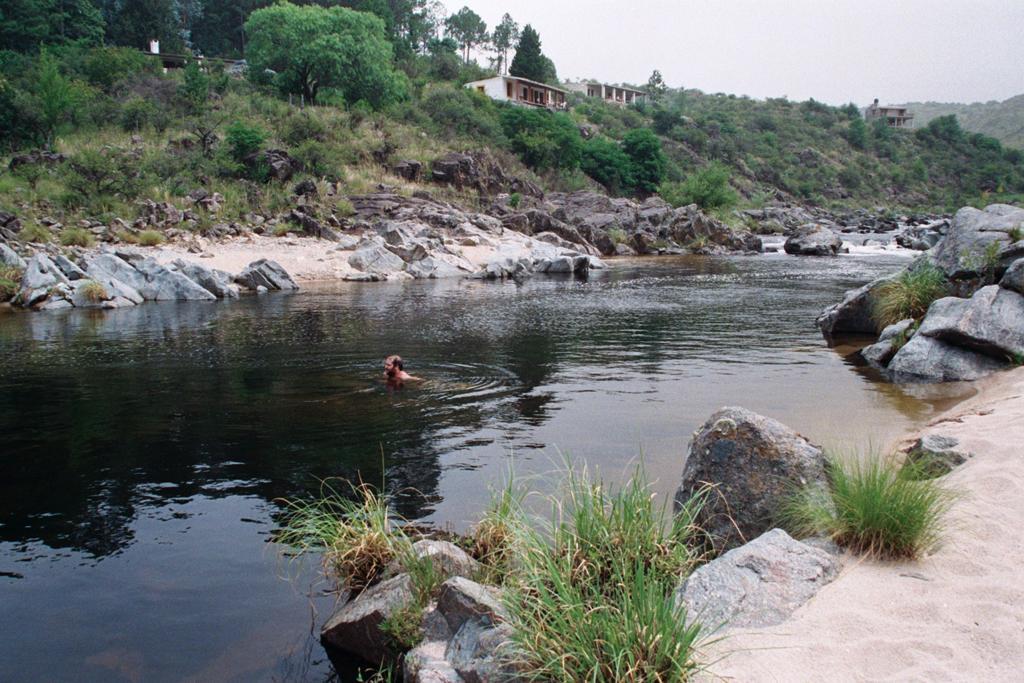Please provide a concise description of this image. There are stones and grass on left and right corner. There is a flow of water in the foreground. There is a person in the water. There are trees at the background. And the sky is at the top 